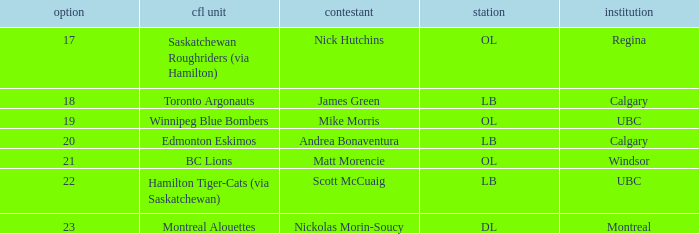For the players who went to calgary, what pick numbers were they? 18, 20. 